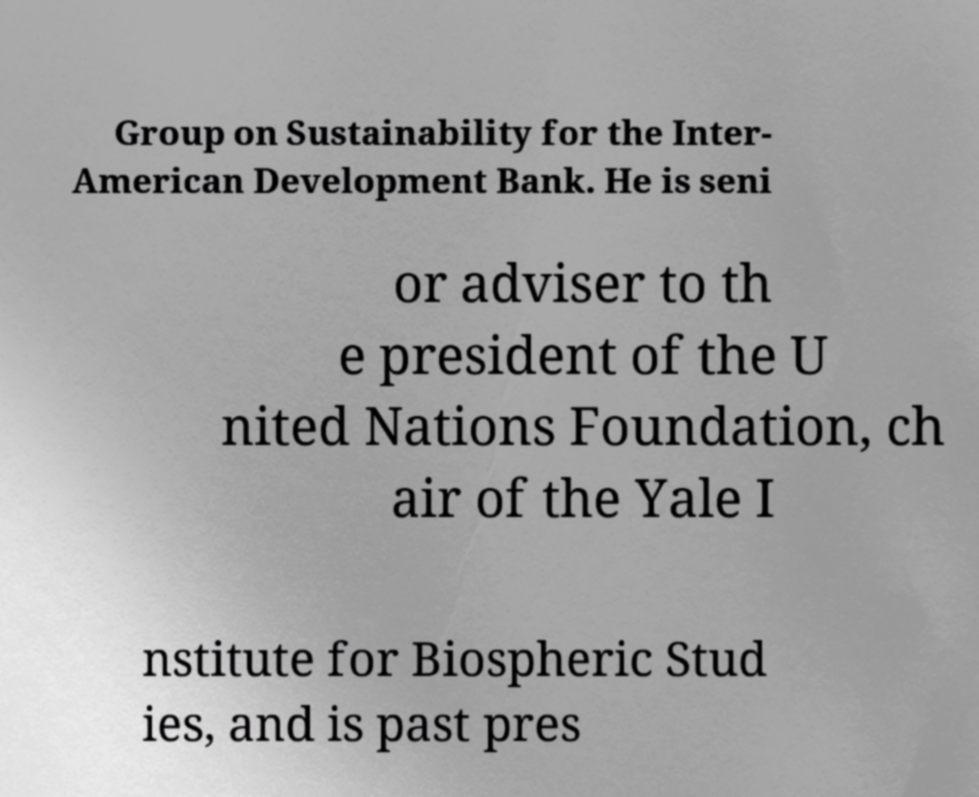Could you assist in decoding the text presented in this image and type it out clearly? Group on Sustainability for the Inter- American Development Bank. He is seni or adviser to th e president of the U nited Nations Foundation, ch air of the Yale I nstitute for Biospheric Stud ies, and is past pres 